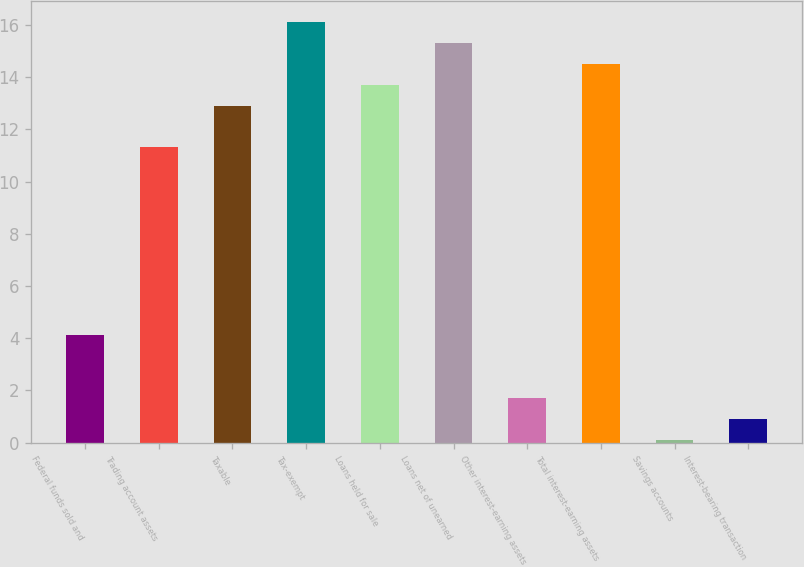Convert chart to OTSL. <chart><loc_0><loc_0><loc_500><loc_500><bar_chart><fcel>Federal funds sold and<fcel>Trading account assets<fcel>Taxable<fcel>Tax-exempt<fcel>Loans held for sale<fcel>Loans net of unearned<fcel>Other interest-earning assets<fcel>Total interest-earning assets<fcel>Savings accounts<fcel>Interest-bearing transaction<nl><fcel>4.11<fcel>11.31<fcel>12.91<fcel>16.11<fcel>13.71<fcel>15.31<fcel>1.71<fcel>14.51<fcel>0.11<fcel>0.91<nl></chart> 